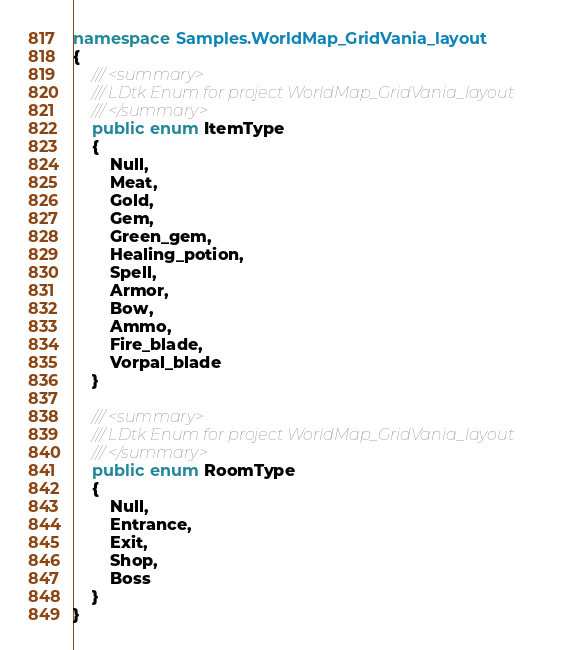<code> <loc_0><loc_0><loc_500><loc_500><_C#_>namespace Samples.WorldMap_GridVania_layout
{
    /// <summary>
    /// LDtk Enum for project WorldMap_GridVania_layout
    /// </summary>
    public enum ItemType
    {
        Null,
        Meat,
        Gold,
        Gem,
        Green_gem,
        Healing_potion,
        Spell,
        Armor,
        Bow,
        Ammo,
        Fire_blade,
        Vorpal_blade
    }

    /// <summary>
    /// LDtk Enum for project WorldMap_GridVania_layout
    /// </summary>
    public enum RoomType
    {
        Null,
        Entrance,
        Exit,
        Shop,
        Boss
    }
}</code> 